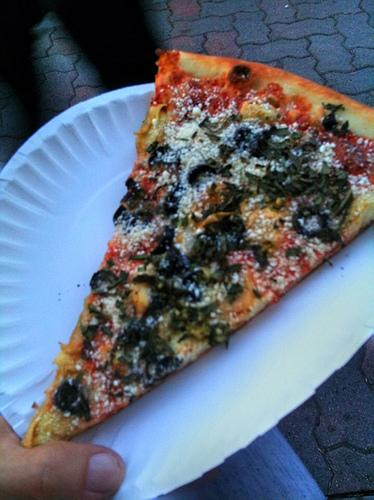Describe the person holding the plate and the surroundings in the image. A man wearing blue jeans holds a white paper plate with a slice of pizza on it, while he stands on a brick ground with shadows. Summarize the scene in the image with a focus on the primary object. A slice of pizza with olives, cheese, and sauce on a white paper plate is held by a person wearing blue jeans standing on cracked brick textured ground. Based on the information provided, how many objects are part of the pizza slice? There are 8 objects that are part of the pizza slice. Analyze the overall sentiment in the image based on visible objects and their interactions. The sentiment is neutral with a hint of positive, as the image showcases a person holding a delicious slice of pizza. What are the main toppings and features of the pizza slice in the image? The pizza slice has white cheese, black olives, green herbs, red sauce, grated parmesan cheese, and crust. Describe the fingernail of the man. broken short thumb nail Explain the arrangement of objects in this image. a slice of pizza on a white paper plate on a brick ground, with blue jeans under the plate What toppings are present on the pizza? black olives, green herbs, and sauce Describe the ground in this image with an adjective. cracked Create a short poem about the pizza in this image. Pizza, oh dearest slice, Does the pizza slice have only cheese and no toppings on it? No, it's not mentioned in the image. Determine the activity taking place in the image. man eating pizza Is there a shadow on the brick ground? (yes/no) yes Create a sentence describing the color of objects in the image. The blue jeans, red sauce, and green herbs add a pop of color to the scene. Identify the type of ground in the park. brick ground Describe the expression of the man in this image. no facial expression visible Identify an event happening in the image. man holding a pizza slice on a white paper plate Describe the texture of the ground. cracked brick textured gray Is the red sauce on the pizza green in color? The instruction is misleading because the red sauce cannot be green in color. What is the color of the jeans worn by the man? blue Create a sentence describing the objects in the image. A man in blue jeans is enjoying a cheese pizza topped with olives, sauce, and herbs on a white paper plate. Which object in the image has scalloped edges? white paper plate What is the color of the sauce on the pizza? red Identify the type of cheese on the pizza. white cheese 